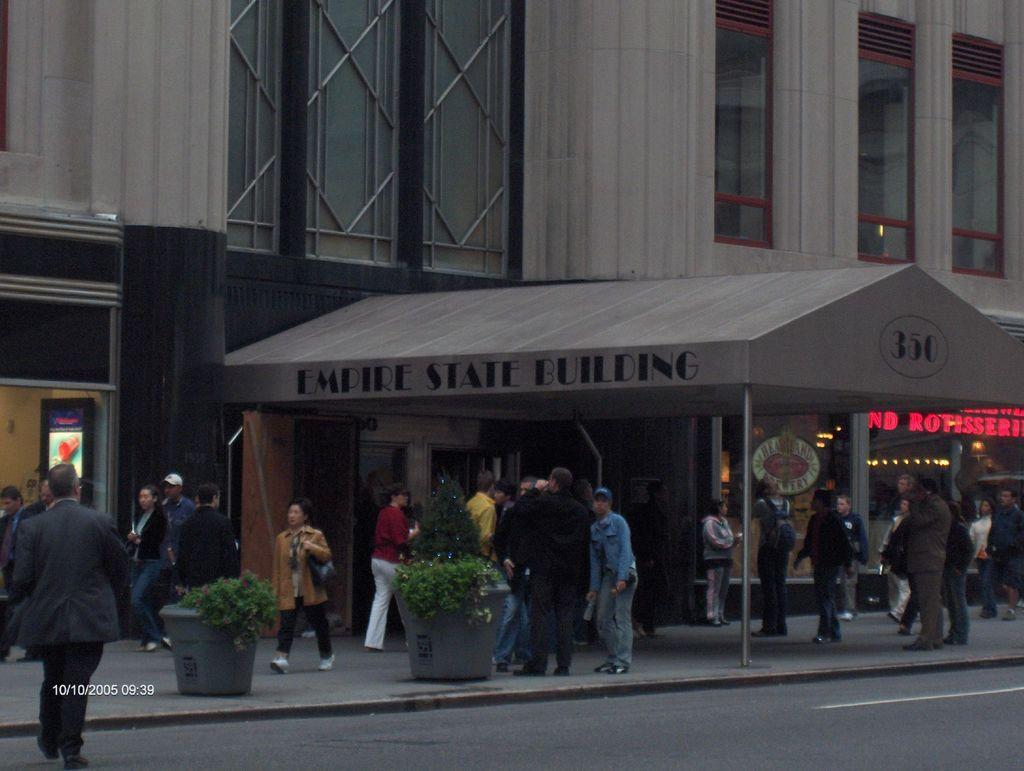How would you summarize this image in a sentence or two? In the foreground of this image, there is a road and on the left, there is a man walking on it. In the background, there are persons walking and standing on the side path, plants, shelter, building and the lights. 